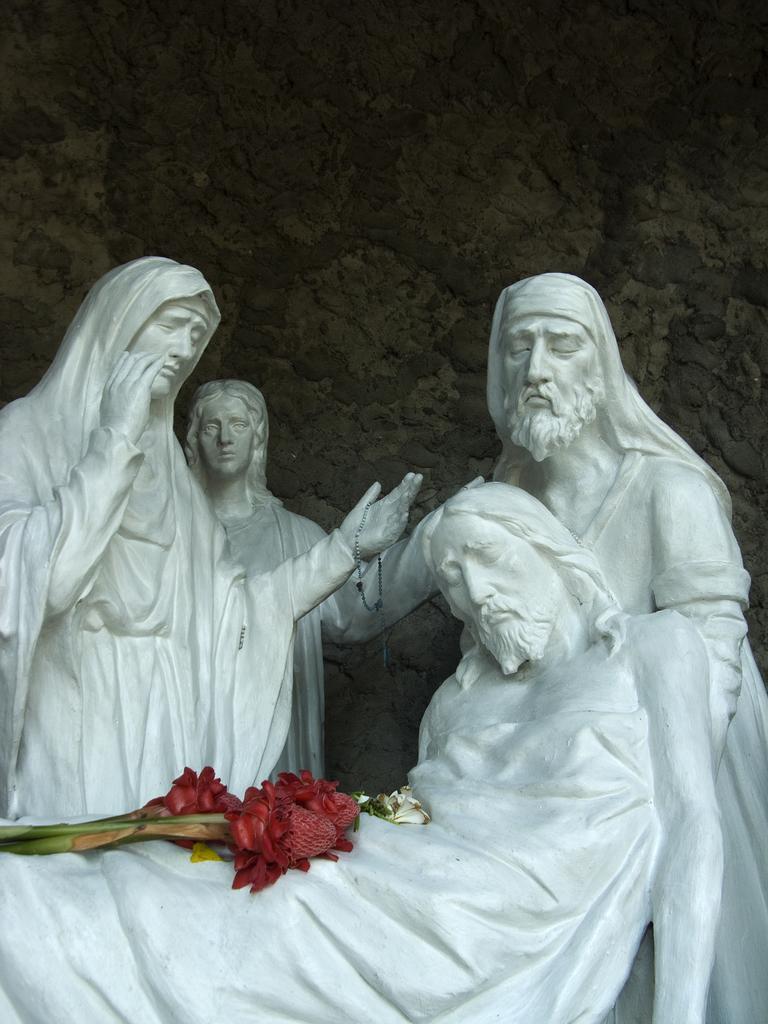How would you summarize this image in a sentence or two? This image consists of sculptures made up of rock. The sculptures are in white color. On the sculpture we can see the flowers. In the background, there is a rock. 